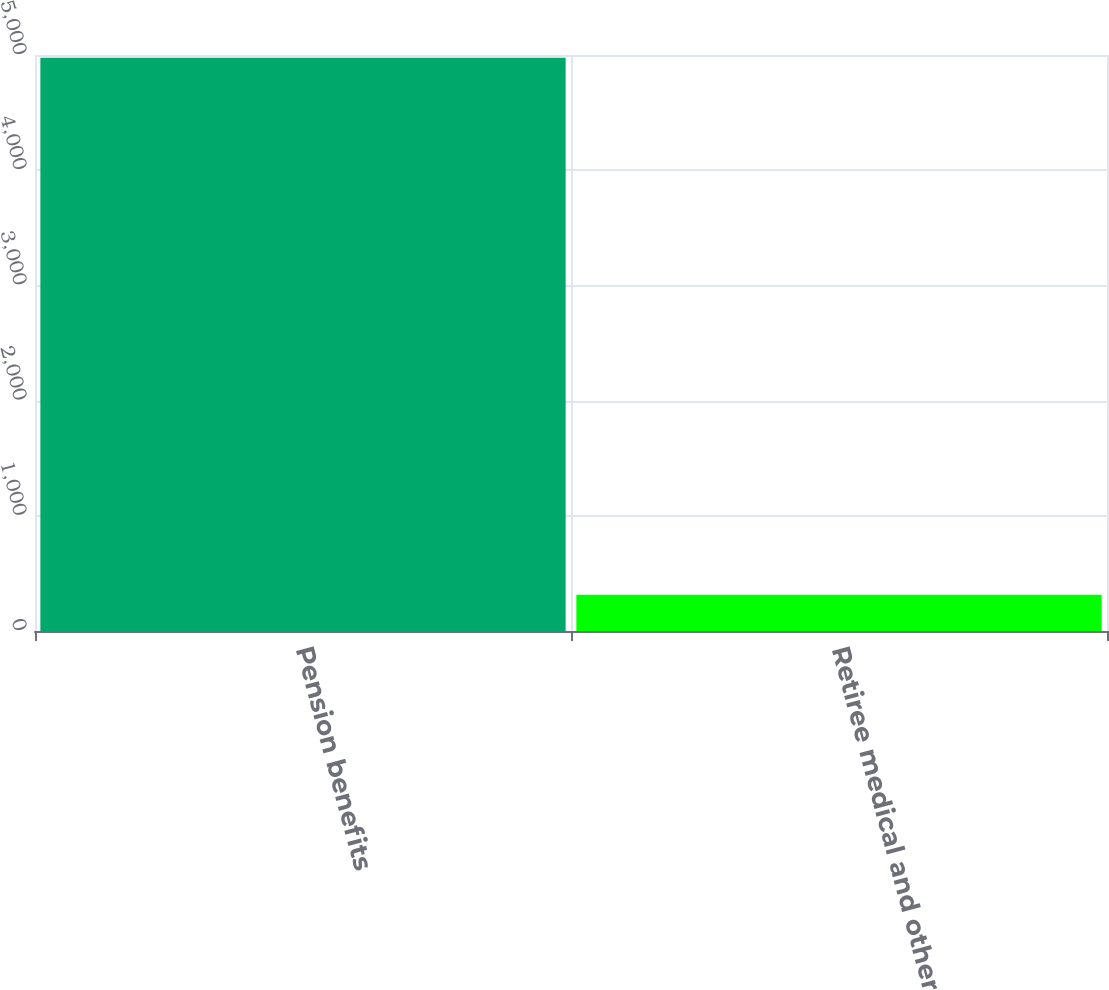<chart> <loc_0><loc_0><loc_500><loc_500><bar_chart><fcel>Pension benefits<fcel>Retiree medical and other<nl><fcel>4976<fcel>315<nl></chart> 